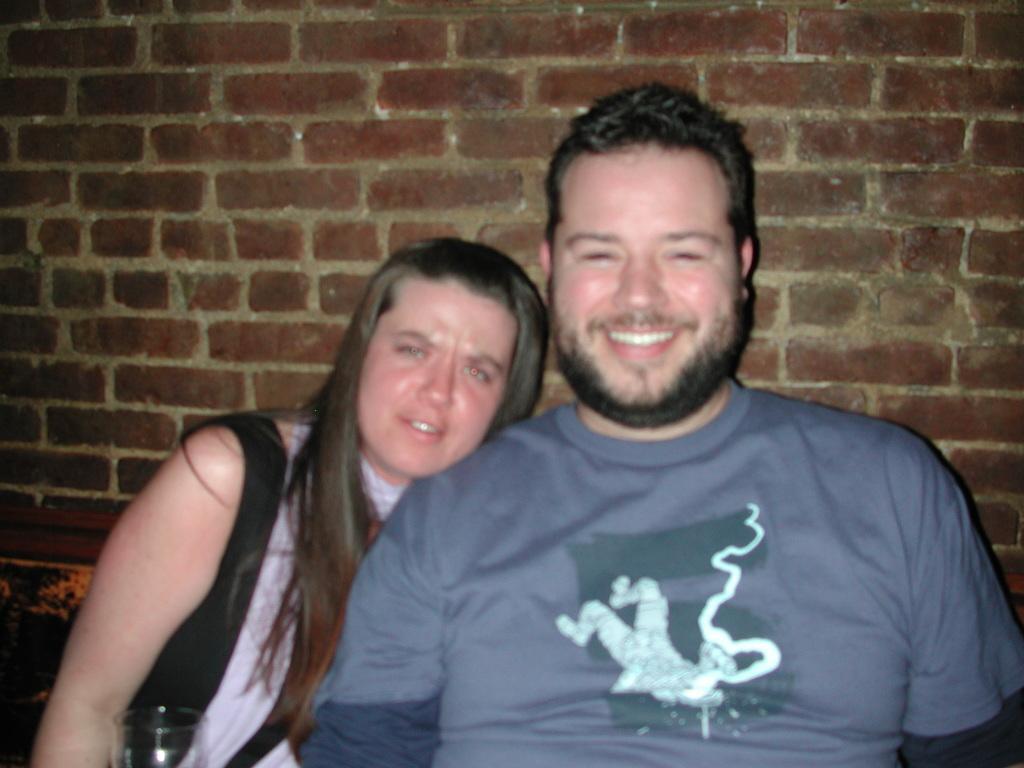Could you give a brief overview of what you see in this image? Here I can see a woman and a man are sitting, smiling and giving pose for the picture. In the bottom left-hand corner there is a glass. At the back of these people there is a wall. 